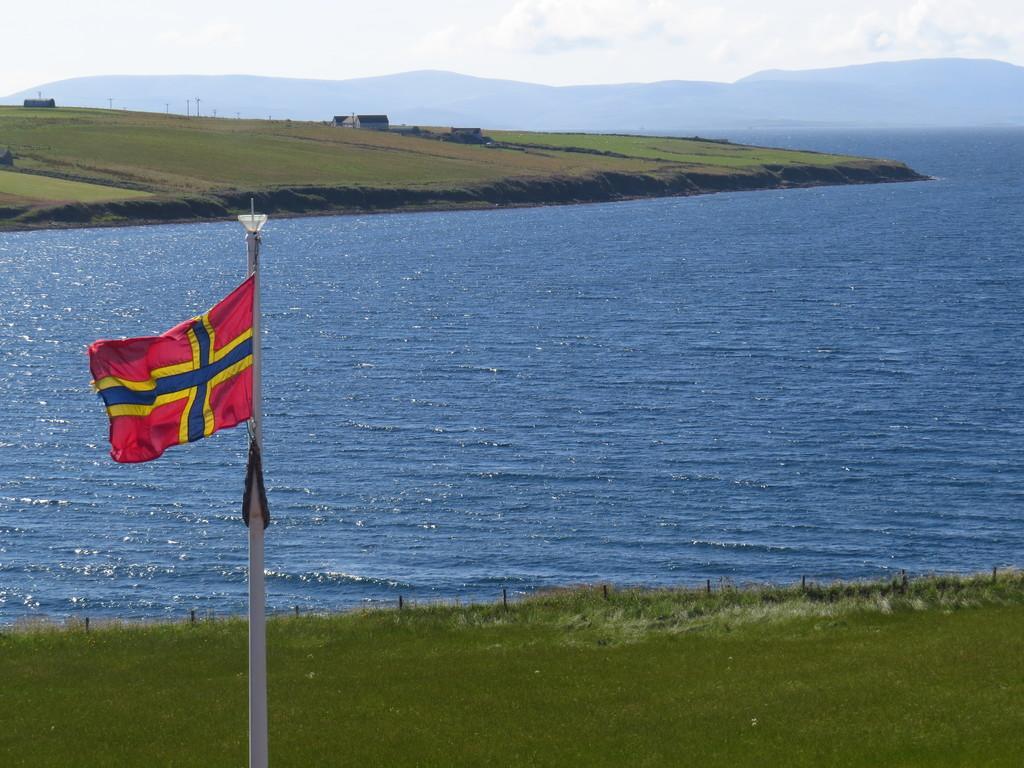Can you describe this image briefly? On the left side of the image we can see a flag. At the bottom there is grass. In the center there is a river. In the background there are sheds, hills and sky. 